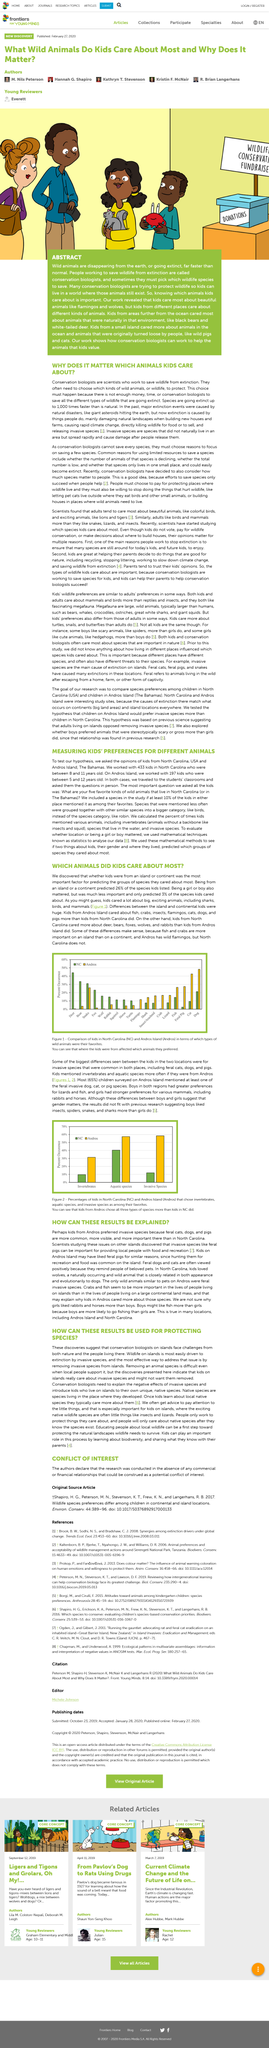Point out several critical features in this image. Modern times have contributed to the extinction of many species due to human actions such as climate change, habitat destruction, hunting and killing of wildlife for food or profit, and the introduction of invasive species into ecosystems. The results of the study indicated that the previous findings suggesting a significant gender difference in the preference for invertebrates was not supported by the data. Instead, the results showed that the gender difference was not significant. The title of the article is "Which Animals Did Kids Care About Most?". Conservation biologists must make difficult choices regarding which animals to save, as they are often limited by limited resources such as money and time. The study was conducted in North Carolina and Andros Island, and the three species represented in the graph were Invertebrates, Aquatic Species, and Invasive Species. 